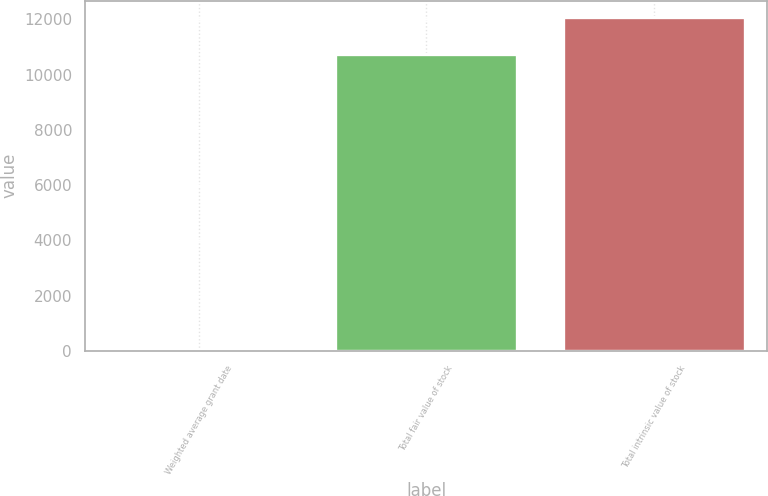Convert chart to OTSL. <chart><loc_0><loc_0><loc_500><loc_500><bar_chart><fcel>Weighted average grant date<fcel>Total fair value of stock<fcel>Total intrinsic value of stock<nl><fcel>16.15<fcel>10748<fcel>12075<nl></chart> 